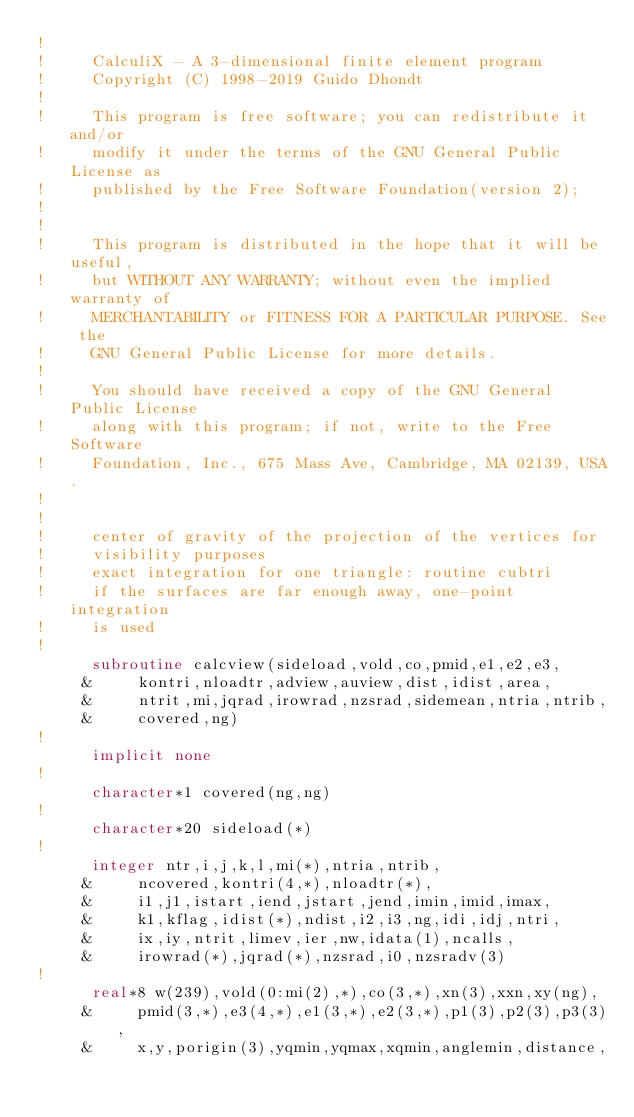<code> <loc_0><loc_0><loc_500><loc_500><_FORTRAN_>!
!     CalculiX - A 3-dimensional finite element program
!     Copyright (C) 1998-2019 Guido Dhondt
!     
!     This program is free software; you can redistribute it and/or
!     modify it under the terms of the GNU General Public License as
!     published by the Free Software Foundation(version 2);
!     
!     
!     This program is distributed in the hope that it will be useful,
!     but WITHOUT ANY WARRANTY; without even the implied warranty of 
!     MERCHANTABILITY or FITNESS FOR A PARTICULAR PURPOSE. See the 
!     GNU General Public License for more details.
!     
!     You should have received a copy of the GNU General Public License
!     along with this program; if not, write to the Free Software
!     Foundation, Inc., 675 Mass Ave, Cambridge, MA 02139, USA.
!    
!
!     center of gravity of the projection of the vertices for
!     visibility purposes
!     exact integration for one triangle: routine cubtri
!     if the surfaces are far enough away, one-point integration
!     is used
! 
      subroutine calcview(sideload,vold,co,pmid,e1,e2,e3,
     &     kontri,nloadtr,adview,auview,dist,idist,area,
     &     ntrit,mi,jqrad,irowrad,nzsrad,sidemean,ntria,ntrib,
     &     covered,ng)
!     
      implicit none
!     
      character*1 covered(ng,ng)
!
      character*20 sideload(*)
!     
      integer ntr,i,j,k,l,mi(*),ntria,ntrib,
     &     ncovered,kontri(4,*),nloadtr(*),
     &     i1,j1,istart,iend,jstart,jend,imin,imid,imax,
     &     k1,kflag,idist(*),ndist,i2,i3,ng,idi,idj,ntri,
     &     ix,iy,ntrit,limev,ier,nw,idata(1),ncalls,
     &     irowrad(*),jqrad(*),nzsrad,i0,nzsradv(3)
!     
      real*8 w(239),vold(0:mi(2),*),co(3,*),xn(3),xxn,xy(ng),
     &     pmid(3,*),e3(4,*),e1(3,*),e2(3,*),p1(3),p2(3),p3(3),
     &     x,y,porigin(3),yqmin,yqmax,xqmin,anglemin,distance,</code> 